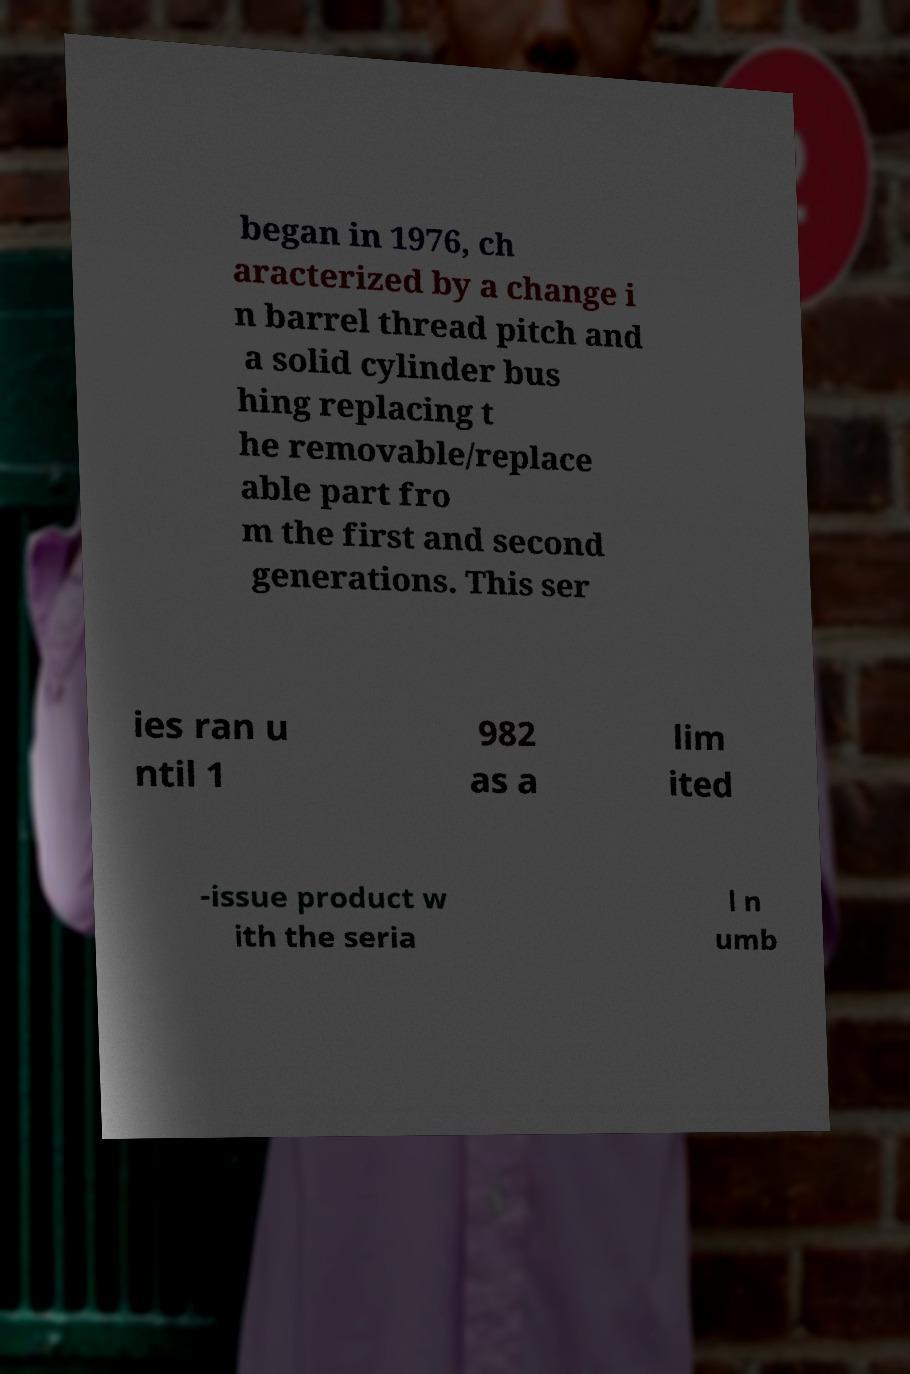Can you accurately transcribe the text from the provided image for me? began in 1976, ch aracterized by a change i n barrel thread pitch and a solid cylinder bus hing replacing t he removable/replace able part fro m the first and second generations. This ser ies ran u ntil 1 982 as a lim ited -issue product w ith the seria l n umb 